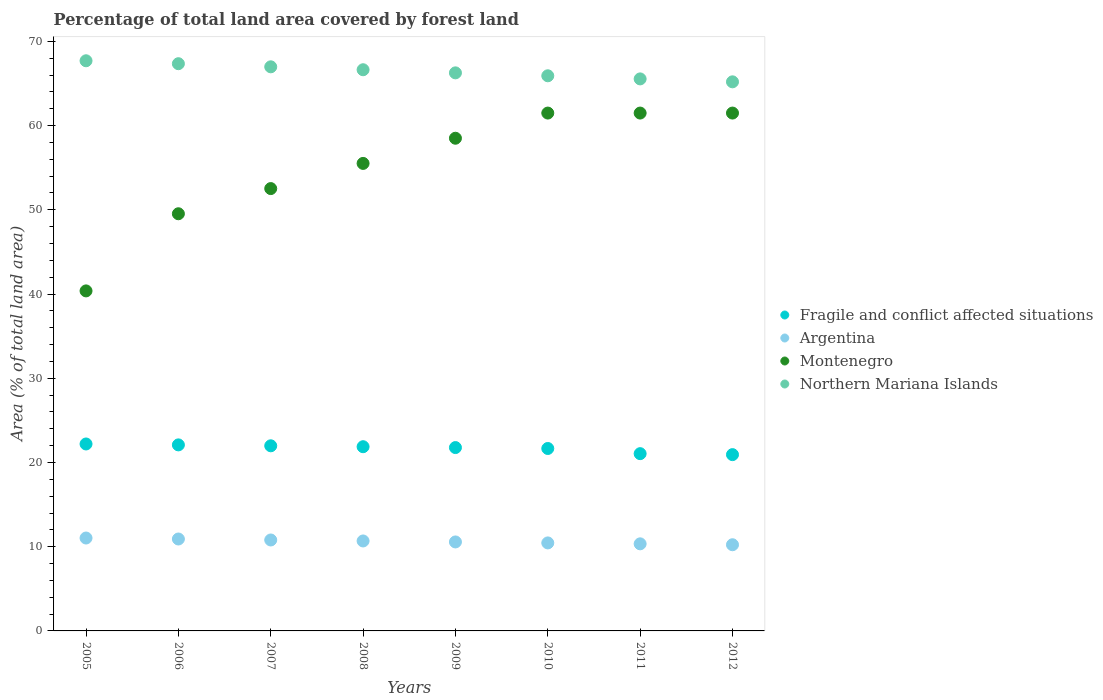Is the number of dotlines equal to the number of legend labels?
Your answer should be very brief. Yes. What is the percentage of forest land in Northern Mariana Islands in 2010?
Your response must be concise. 65.91. Across all years, what is the maximum percentage of forest land in Argentina?
Your response must be concise. 11.03. Across all years, what is the minimum percentage of forest land in Fragile and conflict affected situations?
Your answer should be very brief. 20.93. In which year was the percentage of forest land in Fragile and conflict affected situations minimum?
Offer a very short reply. 2012. What is the total percentage of forest land in Montenegro in the graph?
Offer a very short reply. 440.89. What is the difference between the percentage of forest land in Argentina in 2006 and the percentage of forest land in Montenegro in 2011?
Your answer should be very brief. -50.57. What is the average percentage of forest land in Northern Mariana Islands per year?
Your answer should be very brief. 66.45. In the year 2011, what is the difference between the percentage of forest land in Fragile and conflict affected situations and percentage of forest land in Montenegro?
Provide a short and direct response. -40.44. What is the ratio of the percentage of forest land in Fragile and conflict affected situations in 2008 to that in 2011?
Provide a succinct answer. 1.04. What is the difference between the highest and the lowest percentage of forest land in Argentina?
Your answer should be compact. 0.8. Is the sum of the percentage of forest land in Northern Mariana Islands in 2007 and 2010 greater than the maximum percentage of forest land in Montenegro across all years?
Your answer should be compact. Yes. Is the percentage of forest land in Northern Mariana Islands strictly greater than the percentage of forest land in Argentina over the years?
Provide a succinct answer. Yes. Is the percentage of forest land in Montenegro strictly less than the percentage of forest land in Argentina over the years?
Offer a very short reply. No. How many dotlines are there?
Your response must be concise. 4. How many years are there in the graph?
Provide a succinct answer. 8. Are the values on the major ticks of Y-axis written in scientific E-notation?
Give a very brief answer. No. Does the graph contain grids?
Offer a very short reply. No. Where does the legend appear in the graph?
Provide a short and direct response. Center right. How many legend labels are there?
Give a very brief answer. 4. What is the title of the graph?
Your answer should be very brief. Percentage of total land area covered by forest land. What is the label or title of the Y-axis?
Make the answer very short. Area (% of total land area). What is the Area (% of total land area) in Fragile and conflict affected situations in 2005?
Keep it short and to the point. 22.2. What is the Area (% of total land area) in Argentina in 2005?
Provide a succinct answer. 11.03. What is the Area (% of total land area) in Montenegro in 2005?
Your response must be concise. 40.37. What is the Area (% of total land area) in Northern Mariana Islands in 2005?
Your answer should be very brief. 67.7. What is the Area (% of total land area) in Fragile and conflict affected situations in 2006?
Keep it short and to the point. 22.09. What is the Area (% of total land area) of Argentina in 2006?
Your answer should be compact. 10.91. What is the Area (% of total land area) in Montenegro in 2006?
Your answer should be compact. 49.53. What is the Area (% of total land area) of Northern Mariana Islands in 2006?
Provide a short and direct response. 67.35. What is the Area (% of total land area) of Fragile and conflict affected situations in 2007?
Offer a terse response. 21.98. What is the Area (% of total land area) of Argentina in 2007?
Your response must be concise. 10.8. What is the Area (% of total land area) in Montenegro in 2007?
Ensure brevity in your answer.  52.52. What is the Area (% of total land area) in Northern Mariana Islands in 2007?
Offer a terse response. 66.98. What is the Area (% of total land area) of Fragile and conflict affected situations in 2008?
Provide a short and direct response. 21.87. What is the Area (% of total land area) in Argentina in 2008?
Provide a short and direct response. 10.68. What is the Area (% of total land area) in Montenegro in 2008?
Ensure brevity in your answer.  55.51. What is the Area (% of total land area) in Northern Mariana Islands in 2008?
Give a very brief answer. 66.63. What is the Area (% of total land area) of Fragile and conflict affected situations in 2009?
Your response must be concise. 21.77. What is the Area (% of total land area) of Argentina in 2009?
Keep it short and to the point. 10.57. What is the Area (% of total land area) in Montenegro in 2009?
Provide a succinct answer. 58.5. What is the Area (% of total land area) of Northern Mariana Islands in 2009?
Offer a very short reply. 66.26. What is the Area (% of total land area) in Fragile and conflict affected situations in 2010?
Your answer should be compact. 21.66. What is the Area (% of total land area) in Argentina in 2010?
Your response must be concise. 10.45. What is the Area (% of total land area) in Montenegro in 2010?
Your answer should be compact. 61.49. What is the Area (% of total land area) of Northern Mariana Islands in 2010?
Provide a short and direct response. 65.91. What is the Area (% of total land area) in Fragile and conflict affected situations in 2011?
Your answer should be compact. 21.05. What is the Area (% of total land area) of Argentina in 2011?
Your answer should be very brief. 10.34. What is the Area (% of total land area) of Montenegro in 2011?
Give a very brief answer. 61.49. What is the Area (% of total land area) in Northern Mariana Islands in 2011?
Ensure brevity in your answer.  65.54. What is the Area (% of total land area) of Fragile and conflict affected situations in 2012?
Make the answer very short. 20.93. What is the Area (% of total land area) in Argentina in 2012?
Keep it short and to the point. 10.23. What is the Area (% of total land area) of Montenegro in 2012?
Provide a succinct answer. 61.49. What is the Area (% of total land area) in Northern Mariana Islands in 2012?
Give a very brief answer. 65.2. Across all years, what is the maximum Area (% of total land area) of Fragile and conflict affected situations?
Make the answer very short. 22.2. Across all years, what is the maximum Area (% of total land area) in Argentina?
Your answer should be very brief. 11.03. Across all years, what is the maximum Area (% of total land area) of Montenegro?
Your answer should be compact. 61.49. Across all years, what is the maximum Area (% of total land area) of Northern Mariana Islands?
Your response must be concise. 67.7. Across all years, what is the minimum Area (% of total land area) in Fragile and conflict affected situations?
Offer a terse response. 20.93. Across all years, what is the minimum Area (% of total land area) of Argentina?
Provide a short and direct response. 10.23. Across all years, what is the minimum Area (% of total land area) in Montenegro?
Provide a succinct answer. 40.37. Across all years, what is the minimum Area (% of total land area) in Northern Mariana Islands?
Give a very brief answer. 65.2. What is the total Area (% of total land area) of Fragile and conflict affected situations in the graph?
Ensure brevity in your answer.  173.55. What is the total Area (% of total land area) in Argentina in the graph?
Offer a terse response. 85.01. What is the total Area (% of total land area) in Montenegro in the graph?
Your answer should be very brief. 440.89. What is the total Area (% of total land area) in Northern Mariana Islands in the graph?
Your answer should be compact. 531.57. What is the difference between the Area (% of total land area) of Fragile and conflict affected situations in 2005 and that in 2006?
Your answer should be compact. 0.11. What is the difference between the Area (% of total land area) of Argentina in 2005 and that in 2006?
Your response must be concise. 0.12. What is the difference between the Area (% of total land area) in Montenegro in 2005 and that in 2006?
Keep it short and to the point. -9.16. What is the difference between the Area (% of total land area) in Northern Mariana Islands in 2005 and that in 2006?
Ensure brevity in your answer.  0.35. What is the difference between the Area (% of total land area) of Fragile and conflict affected situations in 2005 and that in 2007?
Your answer should be compact. 0.22. What is the difference between the Area (% of total land area) in Argentina in 2005 and that in 2007?
Your answer should be compact. 0.23. What is the difference between the Area (% of total land area) of Montenegro in 2005 and that in 2007?
Your answer should be very brief. -12.15. What is the difference between the Area (% of total land area) of Northern Mariana Islands in 2005 and that in 2007?
Keep it short and to the point. 0.72. What is the difference between the Area (% of total land area) of Fragile and conflict affected situations in 2005 and that in 2008?
Ensure brevity in your answer.  0.32. What is the difference between the Area (% of total land area) of Argentina in 2005 and that in 2008?
Keep it short and to the point. 0.35. What is the difference between the Area (% of total land area) of Montenegro in 2005 and that in 2008?
Offer a terse response. -15.14. What is the difference between the Area (% of total land area) in Northern Mariana Islands in 2005 and that in 2008?
Your answer should be compact. 1.07. What is the difference between the Area (% of total land area) of Fragile and conflict affected situations in 2005 and that in 2009?
Your answer should be compact. 0.43. What is the difference between the Area (% of total land area) of Argentina in 2005 and that in 2009?
Provide a succinct answer. 0.46. What is the difference between the Area (% of total land area) of Montenegro in 2005 and that in 2009?
Your answer should be very brief. -18.13. What is the difference between the Area (% of total land area) in Northern Mariana Islands in 2005 and that in 2009?
Your answer should be compact. 1.43. What is the difference between the Area (% of total land area) of Fragile and conflict affected situations in 2005 and that in 2010?
Provide a succinct answer. 0.54. What is the difference between the Area (% of total land area) in Argentina in 2005 and that in 2010?
Ensure brevity in your answer.  0.58. What is the difference between the Area (% of total land area) in Montenegro in 2005 and that in 2010?
Keep it short and to the point. -21.12. What is the difference between the Area (% of total land area) in Northern Mariana Islands in 2005 and that in 2010?
Keep it short and to the point. 1.78. What is the difference between the Area (% of total land area) of Fragile and conflict affected situations in 2005 and that in 2011?
Keep it short and to the point. 1.15. What is the difference between the Area (% of total land area) of Argentina in 2005 and that in 2011?
Provide a short and direct response. 0.69. What is the difference between the Area (% of total land area) of Montenegro in 2005 and that in 2011?
Your answer should be very brief. -21.12. What is the difference between the Area (% of total land area) of Northern Mariana Islands in 2005 and that in 2011?
Offer a very short reply. 2.15. What is the difference between the Area (% of total land area) in Fragile and conflict affected situations in 2005 and that in 2012?
Provide a succinct answer. 1.27. What is the difference between the Area (% of total land area) of Argentina in 2005 and that in 2012?
Your answer should be very brief. 0.8. What is the difference between the Area (% of total land area) in Montenegro in 2005 and that in 2012?
Provide a short and direct response. -21.12. What is the difference between the Area (% of total land area) of Northern Mariana Islands in 2005 and that in 2012?
Ensure brevity in your answer.  2.5. What is the difference between the Area (% of total land area) of Fragile and conflict affected situations in 2006 and that in 2007?
Make the answer very short. 0.11. What is the difference between the Area (% of total land area) of Argentina in 2006 and that in 2007?
Give a very brief answer. 0.12. What is the difference between the Area (% of total land area) in Montenegro in 2006 and that in 2007?
Keep it short and to the point. -2.99. What is the difference between the Area (% of total land area) of Northern Mariana Islands in 2006 and that in 2007?
Offer a very short reply. 0.37. What is the difference between the Area (% of total land area) of Fragile and conflict affected situations in 2006 and that in 2008?
Provide a short and direct response. 0.22. What is the difference between the Area (% of total land area) of Argentina in 2006 and that in 2008?
Give a very brief answer. 0.23. What is the difference between the Area (% of total land area) of Montenegro in 2006 and that in 2008?
Provide a succinct answer. -5.98. What is the difference between the Area (% of total land area) in Northern Mariana Islands in 2006 and that in 2008?
Offer a terse response. 0.72. What is the difference between the Area (% of total land area) of Fragile and conflict affected situations in 2006 and that in 2009?
Keep it short and to the point. 0.32. What is the difference between the Area (% of total land area) in Argentina in 2006 and that in 2009?
Offer a terse response. 0.35. What is the difference between the Area (% of total land area) in Montenegro in 2006 and that in 2009?
Give a very brief answer. -8.97. What is the difference between the Area (% of total land area) of Northern Mariana Islands in 2006 and that in 2009?
Your answer should be compact. 1.09. What is the difference between the Area (% of total land area) of Fragile and conflict affected situations in 2006 and that in 2010?
Offer a terse response. 0.43. What is the difference between the Area (% of total land area) of Argentina in 2006 and that in 2010?
Provide a short and direct response. 0.46. What is the difference between the Area (% of total land area) in Montenegro in 2006 and that in 2010?
Your answer should be very brief. -11.96. What is the difference between the Area (% of total land area) of Northern Mariana Islands in 2006 and that in 2010?
Offer a terse response. 1.43. What is the difference between the Area (% of total land area) of Fragile and conflict affected situations in 2006 and that in 2011?
Make the answer very short. 1.04. What is the difference between the Area (% of total land area) in Argentina in 2006 and that in 2011?
Ensure brevity in your answer.  0.57. What is the difference between the Area (% of total land area) in Montenegro in 2006 and that in 2011?
Provide a succinct answer. -11.96. What is the difference between the Area (% of total land area) in Northern Mariana Islands in 2006 and that in 2011?
Your answer should be very brief. 1.8. What is the difference between the Area (% of total land area) in Fragile and conflict affected situations in 2006 and that in 2012?
Offer a terse response. 1.16. What is the difference between the Area (% of total land area) of Argentina in 2006 and that in 2012?
Offer a very short reply. 0.68. What is the difference between the Area (% of total land area) in Montenegro in 2006 and that in 2012?
Ensure brevity in your answer.  -11.96. What is the difference between the Area (% of total land area) in Northern Mariana Islands in 2006 and that in 2012?
Your answer should be very brief. 2.15. What is the difference between the Area (% of total land area) in Fragile and conflict affected situations in 2007 and that in 2008?
Provide a short and direct response. 0.11. What is the difference between the Area (% of total land area) of Argentina in 2007 and that in 2008?
Give a very brief answer. 0.12. What is the difference between the Area (% of total land area) in Montenegro in 2007 and that in 2008?
Provide a short and direct response. -2.99. What is the difference between the Area (% of total land area) in Northern Mariana Islands in 2007 and that in 2008?
Keep it short and to the point. 0.35. What is the difference between the Area (% of total land area) of Fragile and conflict affected situations in 2007 and that in 2009?
Ensure brevity in your answer.  0.21. What is the difference between the Area (% of total land area) in Argentina in 2007 and that in 2009?
Provide a succinct answer. 0.23. What is the difference between the Area (% of total land area) of Montenegro in 2007 and that in 2009?
Your answer should be very brief. -5.98. What is the difference between the Area (% of total land area) in Northern Mariana Islands in 2007 and that in 2009?
Your answer should be very brief. 0.72. What is the difference between the Area (% of total land area) of Fragile and conflict affected situations in 2007 and that in 2010?
Give a very brief answer. 0.32. What is the difference between the Area (% of total land area) in Argentina in 2007 and that in 2010?
Provide a short and direct response. 0.35. What is the difference between the Area (% of total land area) in Montenegro in 2007 and that in 2010?
Your answer should be compact. -8.97. What is the difference between the Area (% of total land area) of Northern Mariana Islands in 2007 and that in 2010?
Provide a short and direct response. 1.07. What is the difference between the Area (% of total land area) in Fragile and conflict affected situations in 2007 and that in 2011?
Your response must be concise. 0.93. What is the difference between the Area (% of total land area) of Argentina in 2007 and that in 2011?
Provide a short and direct response. 0.46. What is the difference between the Area (% of total land area) of Montenegro in 2007 and that in 2011?
Make the answer very short. -8.97. What is the difference between the Area (% of total land area) of Northern Mariana Islands in 2007 and that in 2011?
Offer a terse response. 1.43. What is the difference between the Area (% of total land area) in Fragile and conflict affected situations in 2007 and that in 2012?
Make the answer very short. 1.05. What is the difference between the Area (% of total land area) of Argentina in 2007 and that in 2012?
Make the answer very short. 0.57. What is the difference between the Area (% of total land area) of Montenegro in 2007 and that in 2012?
Provide a short and direct response. -8.97. What is the difference between the Area (% of total land area) of Northern Mariana Islands in 2007 and that in 2012?
Give a very brief answer. 1.78. What is the difference between the Area (% of total land area) in Fragile and conflict affected situations in 2008 and that in 2009?
Give a very brief answer. 0.1. What is the difference between the Area (% of total land area) in Argentina in 2008 and that in 2009?
Keep it short and to the point. 0.12. What is the difference between the Area (% of total land area) of Montenegro in 2008 and that in 2009?
Offer a very short reply. -2.99. What is the difference between the Area (% of total land area) of Northern Mariana Islands in 2008 and that in 2009?
Offer a very short reply. 0.37. What is the difference between the Area (% of total land area) in Fragile and conflict affected situations in 2008 and that in 2010?
Offer a terse response. 0.21. What is the difference between the Area (% of total land area) of Argentina in 2008 and that in 2010?
Ensure brevity in your answer.  0.23. What is the difference between the Area (% of total land area) in Montenegro in 2008 and that in 2010?
Your answer should be compact. -5.98. What is the difference between the Area (% of total land area) of Northern Mariana Islands in 2008 and that in 2010?
Your response must be concise. 0.72. What is the difference between the Area (% of total land area) of Fragile and conflict affected situations in 2008 and that in 2011?
Make the answer very short. 0.83. What is the difference between the Area (% of total land area) of Argentina in 2008 and that in 2011?
Your answer should be very brief. 0.34. What is the difference between the Area (% of total land area) in Montenegro in 2008 and that in 2011?
Give a very brief answer. -5.98. What is the difference between the Area (% of total land area) in Northern Mariana Islands in 2008 and that in 2011?
Provide a succinct answer. 1.09. What is the difference between the Area (% of total land area) in Fragile and conflict affected situations in 2008 and that in 2012?
Offer a very short reply. 0.94. What is the difference between the Area (% of total land area) of Argentina in 2008 and that in 2012?
Ensure brevity in your answer.  0.45. What is the difference between the Area (% of total land area) in Montenegro in 2008 and that in 2012?
Make the answer very short. -5.98. What is the difference between the Area (% of total land area) of Northern Mariana Islands in 2008 and that in 2012?
Provide a succinct answer. 1.43. What is the difference between the Area (% of total land area) of Fragile and conflict affected situations in 2009 and that in 2010?
Your answer should be compact. 0.11. What is the difference between the Area (% of total land area) in Argentina in 2009 and that in 2010?
Offer a terse response. 0.12. What is the difference between the Area (% of total land area) of Montenegro in 2009 and that in 2010?
Make the answer very short. -2.99. What is the difference between the Area (% of total land area) in Northern Mariana Islands in 2009 and that in 2010?
Offer a very short reply. 0.35. What is the difference between the Area (% of total land area) in Fragile and conflict affected situations in 2009 and that in 2011?
Your response must be concise. 0.72. What is the difference between the Area (% of total land area) of Argentina in 2009 and that in 2011?
Provide a short and direct response. 0.22. What is the difference between the Area (% of total land area) in Montenegro in 2009 and that in 2011?
Give a very brief answer. -2.99. What is the difference between the Area (% of total land area) in Northern Mariana Islands in 2009 and that in 2011?
Provide a short and direct response. 0.72. What is the difference between the Area (% of total land area) of Fragile and conflict affected situations in 2009 and that in 2012?
Keep it short and to the point. 0.84. What is the difference between the Area (% of total land area) in Argentina in 2009 and that in 2012?
Give a very brief answer. 0.33. What is the difference between the Area (% of total land area) in Montenegro in 2009 and that in 2012?
Make the answer very short. -2.99. What is the difference between the Area (% of total land area) of Northern Mariana Islands in 2009 and that in 2012?
Your answer should be very brief. 1.07. What is the difference between the Area (% of total land area) in Fragile and conflict affected situations in 2010 and that in 2011?
Provide a succinct answer. 0.61. What is the difference between the Area (% of total land area) in Argentina in 2010 and that in 2011?
Make the answer very short. 0.11. What is the difference between the Area (% of total land area) of Northern Mariana Islands in 2010 and that in 2011?
Your answer should be compact. 0.37. What is the difference between the Area (% of total land area) of Fragile and conflict affected situations in 2010 and that in 2012?
Offer a very short reply. 0.73. What is the difference between the Area (% of total land area) in Argentina in 2010 and that in 2012?
Offer a terse response. 0.22. What is the difference between the Area (% of total land area) in Montenegro in 2010 and that in 2012?
Provide a succinct answer. 0. What is the difference between the Area (% of total land area) of Northern Mariana Islands in 2010 and that in 2012?
Your response must be concise. 0.72. What is the difference between the Area (% of total land area) of Fragile and conflict affected situations in 2011 and that in 2012?
Give a very brief answer. 0.12. What is the difference between the Area (% of total land area) of Argentina in 2011 and that in 2012?
Your answer should be very brief. 0.11. What is the difference between the Area (% of total land area) of Montenegro in 2011 and that in 2012?
Your answer should be very brief. 0. What is the difference between the Area (% of total land area) in Northern Mariana Islands in 2011 and that in 2012?
Your answer should be compact. 0.35. What is the difference between the Area (% of total land area) in Fragile and conflict affected situations in 2005 and the Area (% of total land area) in Argentina in 2006?
Provide a short and direct response. 11.28. What is the difference between the Area (% of total land area) in Fragile and conflict affected situations in 2005 and the Area (% of total land area) in Montenegro in 2006?
Give a very brief answer. -27.33. What is the difference between the Area (% of total land area) in Fragile and conflict affected situations in 2005 and the Area (% of total land area) in Northern Mariana Islands in 2006?
Your answer should be very brief. -45.15. What is the difference between the Area (% of total land area) of Argentina in 2005 and the Area (% of total land area) of Montenegro in 2006?
Make the answer very short. -38.5. What is the difference between the Area (% of total land area) in Argentina in 2005 and the Area (% of total land area) in Northern Mariana Islands in 2006?
Provide a short and direct response. -56.32. What is the difference between the Area (% of total land area) in Montenegro in 2005 and the Area (% of total land area) in Northern Mariana Islands in 2006?
Ensure brevity in your answer.  -26.98. What is the difference between the Area (% of total land area) of Fragile and conflict affected situations in 2005 and the Area (% of total land area) of Argentina in 2007?
Your answer should be very brief. 11.4. What is the difference between the Area (% of total land area) in Fragile and conflict affected situations in 2005 and the Area (% of total land area) in Montenegro in 2007?
Your answer should be very brief. -30.32. What is the difference between the Area (% of total land area) in Fragile and conflict affected situations in 2005 and the Area (% of total land area) in Northern Mariana Islands in 2007?
Give a very brief answer. -44.78. What is the difference between the Area (% of total land area) of Argentina in 2005 and the Area (% of total land area) of Montenegro in 2007?
Your response must be concise. -41.49. What is the difference between the Area (% of total land area) in Argentina in 2005 and the Area (% of total land area) in Northern Mariana Islands in 2007?
Your answer should be compact. -55.95. What is the difference between the Area (% of total land area) of Montenegro in 2005 and the Area (% of total land area) of Northern Mariana Islands in 2007?
Ensure brevity in your answer.  -26.61. What is the difference between the Area (% of total land area) of Fragile and conflict affected situations in 2005 and the Area (% of total land area) of Argentina in 2008?
Your answer should be very brief. 11.52. What is the difference between the Area (% of total land area) of Fragile and conflict affected situations in 2005 and the Area (% of total land area) of Montenegro in 2008?
Your response must be concise. -33.31. What is the difference between the Area (% of total land area) of Fragile and conflict affected situations in 2005 and the Area (% of total land area) of Northern Mariana Islands in 2008?
Make the answer very short. -44.43. What is the difference between the Area (% of total land area) of Argentina in 2005 and the Area (% of total land area) of Montenegro in 2008?
Offer a very short reply. -44.48. What is the difference between the Area (% of total land area) of Argentina in 2005 and the Area (% of total land area) of Northern Mariana Islands in 2008?
Your response must be concise. -55.6. What is the difference between the Area (% of total land area) of Montenegro in 2005 and the Area (% of total land area) of Northern Mariana Islands in 2008?
Give a very brief answer. -26.26. What is the difference between the Area (% of total land area) of Fragile and conflict affected situations in 2005 and the Area (% of total land area) of Argentina in 2009?
Your answer should be compact. 11.63. What is the difference between the Area (% of total land area) in Fragile and conflict affected situations in 2005 and the Area (% of total land area) in Montenegro in 2009?
Your response must be concise. -36.3. What is the difference between the Area (% of total land area) of Fragile and conflict affected situations in 2005 and the Area (% of total land area) of Northern Mariana Islands in 2009?
Make the answer very short. -44.06. What is the difference between the Area (% of total land area) of Argentina in 2005 and the Area (% of total land area) of Montenegro in 2009?
Keep it short and to the point. -47.47. What is the difference between the Area (% of total land area) of Argentina in 2005 and the Area (% of total land area) of Northern Mariana Islands in 2009?
Offer a very short reply. -55.23. What is the difference between the Area (% of total land area) of Montenegro in 2005 and the Area (% of total land area) of Northern Mariana Islands in 2009?
Provide a short and direct response. -25.89. What is the difference between the Area (% of total land area) of Fragile and conflict affected situations in 2005 and the Area (% of total land area) of Argentina in 2010?
Your answer should be very brief. 11.75. What is the difference between the Area (% of total land area) in Fragile and conflict affected situations in 2005 and the Area (% of total land area) in Montenegro in 2010?
Your response must be concise. -39.29. What is the difference between the Area (% of total land area) in Fragile and conflict affected situations in 2005 and the Area (% of total land area) in Northern Mariana Islands in 2010?
Provide a short and direct response. -43.72. What is the difference between the Area (% of total land area) in Argentina in 2005 and the Area (% of total land area) in Montenegro in 2010?
Make the answer very short. -50.46. What is the difference between the Area (% of total land area) of Argentina in 2005 and the Area (% of total land area) of Northern Mariana Islands in 2010?
Your answer should be compact. -54.88. What is the difference between the Area (% of total land area) in Montenegro in 2005 and the Area (% of total land area) in Northern Mariana Islands in 2010?
Provide a succinct answer. -25.54. What is the difference between the Area (% of total land area) in Fragile and conflict affected situations in 2005 and the Area (% of total land area) in Argentina in 2011?
Provide a succinct answer. 11.86. What is the difference between the Area (% of total land area) in Fragile and conflict affected situations in 2005 and the Area (% of total land area) in Montenegro in 2011?
Give a very brief answer. -39.29. What is the difference between the Area (% of total land area) in Fragile and conflict affected situations in 2005 and the Area (% of total land area) in Northern Mariana Islands in 2011?
Make the answer very short. -43.35. What is the difference between the Area (% of total land area) in Argentina in 2005 and the Area (% of total land area) in Montenegro in 2011?
Your response must be concise. -50.46. What is the difference between the Area (% of total land area) in Argentina in 2005 and the Area (% of total land area) in Northern Mariana Islands in 2011?
Give a very brief answer. -54.51. What is the difference between the Area (% of total land area) of Montenegro in 2005 and the Area (% of total land area) of Northern Mariana Islands in 2011?
Your response must be concise. -25.17. What is the difference between the Area (% of total land area) in Fragile and conflict affected situations in 2005 and the Area (% of total land area) in Argentina in 2012?
Offer a terse response. 11.96. What is the difference between the Area (% of total land area) in Fragile and conflict affected situations in 2005 and the Area (% of total land area) in Montenegro in 2012?
Keep it short and to the point. -39.29. What is the difference between the Area (% of total land area) in Fragile and conflict affected situations in 2005 and the Area (% of total land area) in Northern Mariana Islands in 2012?
Keep it short and to the point. -43. What is the difference between the Area (% of total land area) of Argentina in 2005 and the Area (% of total land area) of Montenegro in 2012?
Offer a very short reply. -50.46. What is the difference between the Area (% of total land area) of Argentina in 2005 and the Area (% of total land area) of Northern Mariana Islands in 2012?
Offer a terse response. -54.17. What is the difference between the Area (% of total land area) of Montenegro in 2005 and the Area (% of total land area) of Northern Mariana Islands in 2012?
Provide a short and direct response. -24.82. What is the difference between the Area (% of total land area) of Fragile and conflict affected situations in 2006 and the Area (% of total land area) of Argentina in 2007?
Your answer should be very brief. 11.29. What is the difference between the Area (% of total land area) in Fragile and conflict affected situations in 2006 and the Area (% of total land area) in Montenegro in 2007?
Provide a succinct answer. -30.43. What is the difference between the Area (% of total land area) in Fragile and conflict affected situations in 2006 and the Area (% of total land area) in Northern Mariana Islands in 2007?
Your response must be concise. -44.89. What is the difference between the Area (% of total land area) of Argentina in 2006 and the Area (% of total land area) of Montenegro in 2007?
Provide a short and direct response. -41.61. What is the difference between the Area (% of total land area) in Argentina in 2006 and the Area (% of total land area) in Northern Mariana Islands in 2007?
Give a very brief answer. -56.06. What is the difference between the Area (% of total land area) of Montenegro in 2006 and the Area (% of total land area) of Northern Mariana Islands in 2007?
Your answer should be very brief. -17.45. What is the difference between the Area (% of total land area) of Fragile and conflict affected situations in 2006 and the Area (% of total land area) of Argentina in 2008?
Provide a short and direct response. 11.41. What is the difference between the Area (% of total land area) of Fragile and conflict affected situations in 2006 and the Area (% of total land area) of Montenegro in 2008?
Keep it short and to the point. -33.42. What is the difference between the Area (% of total land area) in Fragile and conflict affected situations in 2006 and the Area (% of total land area) in Northern Mariana Islands in 2008?
Make the answer very short. -44.54. What is the difference between the Area (% of total land area) in Argentina in 2006 and the Area (% of total land area) in Montenegro in 2008?
Make the answer very short. -44.6. What is the difference between the Area (% of total land area) in Argentina in 2006 and the Area (% of total land area) in Northern Mariana Islands in 2008?
Give a very brief answer. -55.72. What is the difference between the Area (% of total land area) of Montenegro in 2006 and the Area (% of total land area) of Northern Mariana Islands in 2008?
Provide a succinct answer. -17.1. What is the difference between the Area (% of total land area) of Fragile and conflict affected situations in 2006 and the Area (% of total land area) of Argentina in 2009?
Provide a short and direct response. 11.52. What is the difference between the Area (% of total land area) of Fragile and conflict affected situations in 2006 and the Area (% of total land area) of Montenegro in 2009?
Your answer should be compact. -36.41. What is the difference between the Area (% of total land area) of Fragile and conflict affected situations in 2006 and the Area (% of total land area) of Northern Mariana Islands in 2009?
Give a very brief answer. -44.17. What is the difference between the Area (% of total land area) of Argentina in 2006 and the Area (% of total land area) of Montenegro in 2009?
Provide a succinct answer. -47.58. What is the difference between the Area (% of total land area) of Argentina in 2006 and the Area (% of total land area) of Northern Mariana Islands in 2009?
Make the answer very short. -55.35. What is the difference between the Area (% of total land area) in Montenegro in 2006 and the Area (% of total land area) in Northern Mariana Islands in 2009?
Your answer should be compact. -16.73. What is the difference between the Area (% of total land area) in Fragile and conflict affected situations in 2006 and the Area (% of total land area) in Argentina in 2010?
Your response must be concise. 11.64. What is the difference between the Area (% of total land area) of Fragile and conflict affected situations in 2006 and the Area (% of total land area) of Montenegro in 2010?
Provide a short and direct response. -39.4. What is the difference between the Area (% of total land area) of Fragile and conflict affected situations in 2006 and the Area (% of total land area) of Northern Mariana Islands in 2010?
Offer a terse response. -43.82. What is the difference between the Area (% of total land area) in Argentina in 2006 and the Area (% of total land area) in Montenegro in 2010?
Your response must be concise. -50.57. What is the difference between the Area (% of total land area) of Argentina in 2006 and the Area (% of total land area) of Northern Mariana Islands in 2010?
Make the answer very short. -55. What is the difference between the Area (% of total land area) in Montenegro in 2006 and the Area (% of total land area) in Northern Mariana Islands in 2010?
Give a very brief answer. -16.38. What is the difference between the Area (% of total land area) in Fragile and conflict affected situations in 2006 and the Area (% of total land area) in Argentina in 2011?
Offer a very short reply. 11.75. What is the difference between the Area (% of total land area) in Fragile and conflict affected situations in 2006 and the Area (% of total land area) in Montenegro in 2011?
Your response must be concise. -39.4. What is the difference between the Area (% of total land area) in Fragile and conflict affected situations in 2006 and the Area (% of total land area) in Northern Mariana Islands in 2011?
Provide a succinct answer. -43.45. What is the difference between the Area (% of total land area) of Argentina in 2006 and the Area (% of total land area) of Montenegro in 2011?
Give a very brief answer. -50.57. What is the difference between the Area (% of total land area) of Argentina in 2006 and the Area (% of total land area) of Northern Mariana Islands in 2011?
Offer a very short reply. -54.63. What is the difference between the Area (% of total land area) of Montenegro in 2006 and the Area (% of total land area) of Northern Mariana Islands in 2011?
Offer a very short reply. -16.01. What is the difference between the Area (% of total land area) of Fragile and conflict affected situations in 2006 and the Area (% of total land area) of Argentina in 2012?
Give a very brief answer. 11.86. What is the difference between the Area (% of total land area) in Fragile and conflict affected situations in 2006 and the Area (% of total land area) in Montenegro in 2012?
Your answer should be very brief. -39.4. What is the difference between the Area (% of total land area) of Fragile and conflict affected situations in 2006 and the Area (% of total land area) of Northern Mariana Islands in 2012?
Your answer should be very brief. -43.11. What is the difference between the Area (% of total land area) in Argentina in 2006 and the Area (% of total land area) in Montenegro in 2012?
Offer a very short reply. -50.57. What is the difference between the Area (% of total land area) of Argentina in 2006 and the Area (% of total land area) of Northern Mariana Islands in 2012?
Your answer should be compact. -54.28. What is the difference between the Area (% of total land area) of Montenegro in 2006 and the Area (% of total land area) of Northern Mariana Islands in 2012?
Provide a succinct answer. -15.66. What is the difference between the Area (% of total land area) of Fragile and conflict affected situations in 2007 and the Area (% of total land area) of Argentina in 2008?
Keep it short and to the point. 11.3. What is the difference between the Area (% of total land area) in Fragile and conflict affected situations in 2007 and the Area (% of total land area) in Montenegro in 2008?
Keep it short and to the point. -33.53. What is the difference between the Area (% of total land area) in Fragile and conflict affected situations in 2007 and the Area (% of total land area) in Northern Mariana Islands in 2008?
Give a very brief answer. -44.65. What is the difference between the Area (% of total land area) in Argentina in 2007 and the Area (% of total land area) in Montenegro in 2008?
Offer a very short reply. -44.71. What is the difference between the Area (% of total land area) in Argentina in 2007 and the Area (% of total land area) in Northern Mariana Islands in 2008?
Ensure brevity in your answer.  -55.83. What is the difference between the Area (% of total land area) in Montenegro in 2007 and the Area (% of total land area) in Northern Mariana Islands in 2008?
Offer a very short reply. -14.11. What is the difference between the Area (% of total land area) of Fragile and conflict affected situations in 2007 and the Area (% of total land area) of Argentina in 2009?
Offer a very short reply. 11.41. What is the difference between the Area (% of total land area) of Fragile and conflict affected situations in 2007 and the Area (% of total land area) of Montenegro in 2009?
Offer a terse response. -36.52. What is the difference between the Area (% of total land area) of Fragile and conflict affected situations in 2007 and the Area (% of total land area) of Northern Mariana Islands in 2009?
Offer a very short reply. -44.28. What is the difference between the Area (% of total land area) of Argentina in 2007 and the Area (% of total land area) of Montenegro in 2009?
Ensure brevity in your answer.  -47.7. What is the difference between the Area (% of total land area) in Argentina in 2007 and the Area (% of total land area) in Northern Mariana Islands in 2009?
Your response must be concise. -55.46. What is the difference between the Area (% of total land area) in Montenegro in 2007 and the Area (% of total land area) in Northern Mariana Islands in 2009?
Give a very brief answer. -13.74. What is the difference between the Area (% of total land area) of Fragile and conflict affected situations in 2007 and the Area (% of total land area) of Argentina in 2010?
Offer a very short reply. 11.53. What is the difference between the Area (% of total land area) in Fragile and conflict affected situations in 2007 and the Area (% of total land area) in Montenegro in 2010?
Give a very brief answer. -39.51. What is the difference between the Area (% of total land area) of Fragile and conflict affected situations in 2007 and the Area (% of total land area) of Northern Mariana Islands in 2010?
Provide a succinct answer. -43.93. What is the difference between the Area (% of total land area) of Argentina in 2007 and the Area (% of total land area) of Montenegro in 2010?
Ensure brevity in your answer.  -50.69. What is the difference between the Area (% of total land area) of Argentina in 2007 and the Area (% of total land area) of Northern Mariana Islands in 2010?
Ensure brevity in your answer.  -55.12. What is the difference between the Area (% of total land area) of Montenegro in 2007 and the Area (% of total land area) of Northern Mariana Islands in 2010?
Offer a very short reply. -13.39. What is the difference between the Area (% of total land area) of Fragile and conflict affected situations in 2007 and the Area (% of total land area) of Argentina in 2011?
Offer a very short reply. 11.64. What is the difference between the Area (% of total land area) of Fragile and conflict affected situations in 2007 and the Area (% of total land area) of Montenegro in 2011?
Ensure brevity in your answer.  -39.51. What is the difference between the Area (% of total land area) in Fragile and conflict affected situations in 2007 and the Area (% of total land area) in Northern Mariana Islands in 2011?
Ensure brevity in your answer.  -43.56. What is the difference between the Area (% of total land area) of Argentina in 2007 and the Area (% of total land area) of Montenegro in 2011?
Provide a succinct answer. -50.69. What is the difference between the Area (% of total land area) of Argentina in 2007 and the Area (% of total land area) of Northern Mariana Islands in 2011?
Keep it short and to the point. -54.75. What is the difference between the Area (% of total land area) in Montenegro in 2007 and the Area (% of total land area) in Northern Mariana Islands in 2011?
Your response must be concise. -13.02. What is the difference between the Area (% of total land area) in Fragile and conflict affected situations in 2007 and the Area (% of total land area) in Argentina in 2012?
Your response must be concise. 11.75. What is the difference between the Area (% of total land area) in Fragile and conflict affected situations in 2007 and the Area (% of total land area) in Montenegro in 2012?
Offer a very short reply. -39.51. What is the difference between the Area (% of total land area) of Fragile and conflict affected situations in 2007 and the Area (% of total land area) of Northern Mariana Islands in 2012?
Your answer should be compact. -43.22. What is the difference between the Area (% of total land area) in Argentina in 2007 and the Area (% of total land area) in Montenegro in 2012?
Offer a very short reply. -50.69. What is the difference between the Area (% of total land area) of Argentina in 2007 and the Area (% of total land area) of Northern Mariana Islands in 2012?
Your answer should be compact. -54.4. What is the difference between the Area (% of total land area) in Montenegro in 2007 and the Area (% of total land area) in Northern Mariana Islands in 2012?
Your answer should be very brief. -12.68. What is the difference between the Area (% of total land area) of Fragile and conflict affected situations in 2008 and the Area (% of total land area) of Argentina in 2009?
Provide a short and direct response. 11.31. What is the difference between the Area (% of total land area) in Fragile and conflict affected situations in 2008 and the Area (% of total land area) in Montenegro in 2009?
Your response must be concise. -36.63. What is the difference between the Area (% of total land area) of Fragile and conflict affected situations in 2008 and the Area (% of total land area) of Northern Mariana Islands in 2009?
Keep it short and to the point. -44.39. What is the difference between the Area (% of total land area) in Argentina in 2008 and the Area (% of total land area) in Montenegro in 2009?
Ensure brevity in your answer.  -47.82. What is the difference between the Area (% of total land area) in Argentina in 2008 and the Area (% of total land area) in Northern Mariana Islands in 2009?
Offer a terse response. -55.58. What is the difference between the Area (% of total land area) in Montenegro in 2008 and the Area (% of total land area) in Northern Mariana Islands in 2009?
Keep it short and to the point. -10.75. What is the difference between the Area (% of total land area) in Fragile and conflict affected situations in 2008 and the Area (% of total land area) in Argentina in 2010?
Your answer should be compact. 11.42. What is the difference between the Area (% of total land area) of Fragile and conflict affected situations in 2008 and the Area (% of total land area) of Montenegro in 2010?
Offer a terse response. -39.61. What is the difference between the Area (% of total land area) in Fragile and conflict affected situations in 2008 and the Area (% of total land area) in Northern Mariana Islands in 2010?
Provide a succinct answer. -44.04. What is the difference between the Area (% of total land area) in Argentina in 2008 and the Area (% of total land area) in Montenegro in 2010?
Ensure brevity in your answer.  -50.81. What is the difference between the Area (% of total land area) of Argentina in 2008 and the Area (% of total land area) of Northern Mariana Islands in 2010?
Provide a short and direct response. -55.23. What is the difference between the Area (% of total land area) in Montenegro in 2008 and the Area (% of total land area) in Northern Mariana Islands in 2010?
Your answer should be very brief. -10.4. What is the difference between the Area (% of total land area) in Fragile and conflict affected situations in 2008 and the Area (% of total land area) in Argentina in 2011?
Offer a terse response. 11.53. What is the difference between the Area (% of total land area) of Fragile and conflict affected situations in 2008 and the Area (% of total land area) of Montenegro in 2011?
Keep it short and to the point. -39.61. What is the difference between the Area (% of total land area) of Fragile and conflict affected situations in 2008 and the Area (% of total land area) of Northern Mariana Islands in 2011?
Give a very brief answer. -43.67. What is the difference between the Area (% of total land area) in Argentina in 2008 and the Area (% of total land area) in Montenegro in 2011?
Offer a very short reply. -50.81. What is the difference between the Area (% of total land area) in Argentina in 2008 and the Area (% of total land area) in Northern Mariana Islands in 2011?
Provide a succinct answer. -54.86. What is the difference between the Area (% of total land area) of Montenegro in 2008 and the Area (% of total land area) of Northern Mariana Islands in 2011?
Give a very brief answer. -10.03. What is the difference between the Area (% of total land area) of Fragile and conflict affected situations in 2008 and the Area (% of total land area) of Argentina in 2012?
Your response must be concise. 11.64. What is the difference between the Area (% of total land area) of Fragile and conflict affected situations in 2008 and the Area (% of total land area) of Montenegro in 2012?
Keep it short and to the point. -39.61. What is the difference between the Area (% of total land area) in Fragile and conflict affected situations in 2008 and the Area (% of total land area) in Northern Mariana Islands in 2012?
Ensure brevity in your answer.  -43.32. What is the difference between the Area (% of total land area) of Argentina in 2008 and the Area (% of total land area) of Montenegro in 2012?
Make the answer very short. -50.81. What is the difference between the Area (% of total land area) of Argentina in 2008 and the Area (% of total land area) of Northern Mariana Islands in 2012?
Offer a terse response. -54.51. What is the difference between the Area (% of total land area) in Montenegro in 2008 and the Area (% of total land area) in Northern Mariana Islands in 2012?
Your answer should be compact. -9.69. What is the difference between the Area (% of total land area) in Fragile and conflict affected situations in 2009 and the Area (% of total land area) in Argentina in 2010?
Provide a succinct answer. 11.32. What is the difference between the Area (% of total land area) in Fragile and conflict affected situations in 2009 and the Area (% of total land area) in Montenegro in 2010?
Provide a short and direct response. -39.72. What is the difference between the Area (% of total land area) of Fragile and conflict affected situations in 2009 and the Area (% of total land area) of Northern Mariana Islands in 2010?
Offer a very short reply. -44.14. What is the difference between the Area (% of total land area) of Argentina in 2009 and the Area (% of total land area) of Montenegro in 2010?
Make the answer very short. -50.92. What is the difference between the Area (% of total land area) in Argentina in 2009 and the Area (% of total land area) in Northern Mariana Islands in 2010?
Offer a terse response. -55.35. What is the difference between the Area (% of total land area) of Montenegro in 2009 and the Area (% of total land area) of Northern Mariana Islands in 2010?
Ensure brevity in your answer.  -7.41. What is the difference between the Area (% of total land area) in Fragile and conflict affected situations in 2009 and the Area (% of total land area) in Argentina in 2011?
Ensure brevity in your answer.  11.43. What is the difference between the Area (% of total land area) of Fragile and conflict affected situations in 2009 and the Area (% of total land area) of Montenegro in 2011?
Offer a very short reply. -39.72. What is the difference between the Area (% of total land area) in Fragile and conflict affected situations in 2009 and the Area (% of total land area) in Northern Mariana Islands in 2011?
Give a very brief answer. -43.77. What is the difference between the Area (% of total land area) in Argentina in 2009 and the Area (% of total land area) in Montenegro in 2011?
Your response must be concise. -50.92. What is the difference between the Area (% of total land area) of Argentina in 2009 and the Area (% of total land area) of Northern Mariana Islands in 2011?
Provide a succinct answer. -54.98. What is the difference between the Area (% of total land area) in Montenegro in 2009 and the Area (% of total land area) in Northern Mariana Islands in 2011?
Ensure brevity in your answer.  -7.05. What is the difference between the Area (% of total land area) in Fragile and conflict affected situations in 2009 and the Area (% of total land area) in Argentina in 2012?
Make the answer very short. 11.54. What is the difference between the Area (% of total land area) of Fragile and conflict affected situations in 2009 and the Area (% of total land area) of Montenegro in 2012?
Offer a very short reply. -39.72. What is the difference between the Area (% of total land area) in Fragile and conflict affected situations in 2009 and the Area (% of total land area) in Northern Mariana Islands in 2012?
Ensure brevity in your answer.  -43.43. What is the difference between the Area (% of total land area) of Argentina in 2009 and the Area (% of total land area) of Montenegro in 2012?
Your answer should be very brief. -50.92. What is the difference between the Area (% of total land area) of Argentina in 2009 and the Area (% of total land area) of Northern Mariana Islands in 2012?
Keep it short and to the point. -54.63. What is the difference between the Area (% of total land area) in Montenegro in 2009 and the Area (% of total land area) in Northern Mariana Islands in 2012?
Provide a succinct answer. -6.7. What is the difference between the Area (% of total land area) of Fragile and conflict affected situations in 2010 and the Area (% of total land area) of Argentina in 2011?
Offer a very short reply. 11.32. What is the difference between the Area (% of total land area) in Fragile and conflict affected situations in 2010 and the Area (% of total land area) in Montenegro in 2011?
Ensure brevity in your answer.  -39.83. What is the difference between the Area (% of total land area) in Fragile and conflict affected situations in 2010 and the Area (% of total land area) in Northern Mariana Islands in 2011?
Give a very brief answer. -43.88. What is the difference between the Area (% of total land area) in Argentina in 2010 and the Area (% of total land area) in Montenegro in 2011?
Your response must be concise. -51.04. What is the difference between the Area (% of total land area) in Argentina in 2010 and the Area (% of total land area) in Northern Mariana Islands in 2011?
Ensure brevity in your answer.  -55.09. What is the difference between the Area (% of total land area) in Montenegro in 2010 and the Area (% of total land area) in Northern Mariana Islands in 2011?
Offer a terse response. -4.06. What is the difference between the Area (% of total land area) of Fragile and conflict affected situations in 2010 and the Area (% of total land area) of Argentina in 2012?
Provide a short and direct response. 11.43. What is the difference between the Area (% of total land area) of Fragile and conflict affected situations in 2010 and the Area (% of total land area) of Montenegro in 2012?
Ensure brevity in your answer.  -39.83. What is the difference between the Area (% of total land area) in Fragile and conflict affected situations in 2010 and the Area (% of total land area) in Northern Mariana Islands in 2012?
Offer a terse response. -43.53. What is the difference between the Area (% of total land area) of Argentina in 2010 and the Area (% of total land area) of Montenegro in 2012?
Give a very brief answer. -51.04. What is the difference between the Area (% of total land area) of Argentina in 2010 and the Area (% of total land area) of Northern Mariana Islands in 2012?
Your answer should be compact. -54.75. What is the difference between the Area (% of total land area) in Montenegro in 2010 and the Area (% of total land area) in Northern Mariana Islands in 2012?
Make the answer very short. -3.71. What is the difference between the Area (% of total land area) in Fragile and conflict affected situations in 2011 and the Area (% of total land area) in Argentina in 2012?
Ensure brevity in your answer.  10.82. What is the difference between the Area (% of total land area) in Fragile and conflict affected situations in 2011 and the Area (% of total land area) in Montenegro in 2012?
Your response must be concise. -40.44. What is the difference between the Area (% of total land area) of Fragile and conflict affected situations in 2011 and the Area (% of total land area) of Northern Mariana Islands in 2012?
Provide a short and direct response. -44.15. What is the difference between the Area (% of total land area) in Argentina in 2011 and the Area (% of total land area) in Montenegro in 2012?
Ensure brevity in your answer.  -51.15. What is the difference between the Area (% of total land area) in Argentina in 2011 and the Area (% of total land area) in Northern Mariana Islands in 2012?
Make the answer very short. -54.85. What is the difference between the Area (% of total land area) in Montenegro in 2011 and the Area (% of total land area) in Northern Mariana Islands in 2012?
Give a very brief answer. -3.71. What is the average Area (% of total land area) in Fragile and conflict affected situations per year?
Your answer should be very brief. 21.69. What is the average Area (% of total land area) of Argentina per year?
Ensure brevity in your answer.  10.63. What is the average Area (% of total land area) in Montenegro per year?
Make the answer very short. 55.11. What is the average Area (% of total land area) in Northern Mariana Islands per year?
Keep it short and to the point. 66.45. In the year 2005, what is the difference between the Area (% of total land area) in Fragile and conflict affected situations and Area (% of total land area) in Argentina?
Offer a very short reply. 11.17. In the year 2005, what is the difference between the Area (% of total land area) in Fragile and conflict affected situations and Area (% of total land area) in Montenegro?
Make the answer very short. -18.17. In the year 2005, what is the difference between the Area (% of total land area) in Fragile and conflict affected situations and Area (% of total land area) in Northern Mariana Islands?
Give a very brief answer. -45.5. In the year 2005, what is the difference between the Area (% of total land area) of Argentina and Area (% of total land area) of Montenegro?
Ensure brevity in your answer.  -29.34. In the year 2005, what is the difference between the Area (% of total land area) in Argentina and Area (% of total land area) in Northern Mariana Islands?
Your answer should be very brief. -56.67. In the year 2005, what is the difference between the Area (% of total land area) in Montenegro and Area (% of total land area) in Northern Mariana Islands?
Offer a terse response. -27.32. In the year 2006, what is the difference between the Area (% of total land area) of Fragile and conflict affected situations and Area (% of total land area) of Argentina?
Offer a very short reply. 11.17. In the year 2006, what is the difference between the Area (% of total land area) in Fragile and conflict affected situations and Area (% of total land area) in Montenegro?
Keep it short and to the point. -27.44. In the year 2006, what is the difference between the Area (% of total land area) in Fragile and conflict affected situations and Area (% of total land area) in Northern Mariana Islands?
Your answer should be very brief. -45.26. In the year 2006, what is the difference between the Area (% of total land area) in Argentina and Area (% of total land area) in Montenegro?
Your answer should be very brief. -38.62. In the year 2006, what is the difference between the Area (% of total land area) of Argentina and Area (% of total land area) of Northern Mariana Islands?
Your answer should be compact. -56.43. In the year 2006, what is the difference between the Area (% of total land area) in Montenegro and Area (% of total land area) in Northern Mariana Islands?
Your answer should be very brief. -17.82. In the year 2007, what is the difference between the Area (% of total land area) of Fragile and conflict affected situations and Area (% of total land area) of Argentina?
Keep it short and to the point. 11.18. In the year 2007, what is the difference between the Area (% of total land area) of Fragile and conflict affected situations and Area (% of total land area) of Montenegro?
Your response must be concise. -30.54. In the year 2007, what is the difference between the Area (% of total land area) in Fragile and conflict affected situations and Area (% of total land area) in Northern Mariana Islands?
Give a very brief answer. -45. In the year 2007, what is the difference between the Area (% of total land area) of Argentina and Area (% of total land area) of Montenegro?
Offer a very short reply. -41.72. In the year 2007, what is the difference between the Area (% of total land area) in Argentina and Area (% of total land area) in Northern Mariana Islands?
Offer a terse response. -56.18. In the year 2007, what is the difference between the Area (% of total land area) in Montenegro and Area (% of total land area) in Northern Mariana Islands?
Your answer should be very brief. -14.46. In the year 2008, what is the difference between the Area (% of total land area) in Fragile and conflict affected situations and Area (% of total land area) in Argentina?
Make the answer very short. 11.19. In the year 2008, what is the difference between the Area (% of total land area) in Fragile and conflict affected situations and Area (% of total land area) in Montenegro?
Your answer should be compact. -33.64. In the year 2008, what is the difference between the Area (% of total land area) in Fragile and conflict affected situations and Area (% of total land area) in Northern Mariana Islands?
Make the answer very short. -44.76. In the year 2008, what is the difference between the Area (% of total land area) in Argentina and Area (% of total land area) in Montenegro?
Provide a short and direct response. -44.83. In the year 2008, what is the difference between the Area (% of total land area) in Argentina and Area (% of total land area) in Northern Mariana Islands?
Provide a short and direct response. -55.95. In the year 2008, what is the difference between the Area (% of total land area) in Montenegro and Area (% of total land area) in Northern Mariana Islands?
Provide a succinct answer. -11.12. In the year 2009, what is the difference between the Area (% of total land area) in Fragile and conflict affected situations and Area (% of total land area) in Argentina?
Keep it short and to the point. 11.2. In the year 2009, what is the difference between the Area (% of total land area) in Fragile and conflict affected situations and Area (% of total land area) in Montenegro?
Offer a very short reply. -36.73. In the year 2009, what is the difference between the Area (% of total land area) in Fragile and conflict affected situations and Area (% of total land area) in Northern Mariana Islands?
Your answer should be very brief. -44.49. In the year 2009, what is the difference between the Area (% of total land area) in Argentina and Area (% of total land area) in Montenegro?
Your response must be concise. -47.93. In the year 2009, what is the difference between the Area (% of total land area) of Argentina and Area (% of total land area) of Northern Mariana Islands?
Keep it short and to the point. -55.7. In the year 2009, what is the difference between the Area (% of total land area) of Montenegro and Area (% of total land area) of Northern Mariana Islands?
Offer a very short reply. -7.76. In the year 2010, what is the difference between the Area (% of total land area) of Fragile and conflict affected situations and Area (% of total land area) of Argentina?
Your answer should be compact. 11.21. In the year 2010, what is the difference between the Area (% of total land area) of Fragile and conflict affected situations and Area (% of total land area) of Montenegro?
Give a very brief answer. -39.83. In the year 2010, what is the difference between the Area (% of total land area) of Fragile and conflict affected situations and Area (% of total land area) of Northern Mariana Islands?
Offer a terse response. -44.25. In the year 2010, what is the difference between the Area (% of total land area) of Argentina and Area (% of total land area) of Montenegro?
Ensure brevity in your answer.  -51.04. In the year 2010, what is the difference between the Area (% of total land area) of Argentina and Area (% of total land area) of Northern Mariana Islands?
Keep it short and to the point. -55.46. In the year 2010, what is the difference between the Area (% of total land area) of Montenegro and Area (% of total land area) of Northern Mariana Islands?
Provide a succinct answer. -4.43. In the year 2011, what is the difference between the Area (% of total land area) of Fragile and conflict affected situations and Area (% of total land area) of Argentina?
Provide a succinct answer. 10.71. In the year 2011, what is the difference between the Area (% of total land area) of Fragile and conflict affected situations and Area (% of total land area) of Montenegro?
Your answer should be very brief. -40.44. In the year 2011, what is the difference between the Area (% of total land area) of Fragile and conflict affected situations and Area (% of total land area) of Northern Mariana Islands?
Provide a short and direct response. -44.5. In the year 2011, what is the difference between the Area (% of total land area) of Argentina and Area (% of total land area) of Montenegro?
Give a very brief answer. -51.15. In the year 2011, what is the difference between the Area (% of total land area) of Argentina and Area (% of total land area) of Northern Mariana Islands?
Your answer should be compact. -55.2. In the year 2011, what is the difference between the Area (% of total land area) of Montenegro and Area (% of total land area) of Northern Mariana Islands?
Provide a succinct answer. -4.06. In the year 2012, what is the difference between the Area (% of total land area) in Fragile and conflict affected situations and Area (% of total land area) in Argentina?
Your answer should be very brief. 10.7. In the year 2012, what is the difference between the Area (% of total land area) of Fragile and conflict affected situations and Area (% of total land area) of Montenegro?
Make the answer very short. -40.56. In the year 2012, what is the difference between the Area (% of total land area) in Fragile and conflict affected situations and Area (% of total land area) in Northern Mariana Islands?
Ensure brevity in your answer.  -44.26. In the year 2012, what is the difference between the Area (% of total land area) in Argentina and Area (% of total land area) in Montenegro?
Your response must be concise. -51.25. In the year 2012, what is the difference between the Area (% of total land area) in Argentina and Area (% of total land area) in Northern Mariana Islands?
Give a very brief answer. -54.96. In the year 2012, what is the difference between the Area (% of total land area) in Montenegro and Area (% of total land area) in Northern Mariana Islands?
Ensure brevity in your answer.  -3.71. What is the ratio of the Area (% of total land area) of Argentina in 2005 to that in 2006?
Provide a succinct answer. 1.01. What is the ratio of the Area (% of total land area) of Montenegro in 2005 to that in 2006?
Your response must be concise. 0.82. What is the ratio of the Area (% of total land area) in Northern Mariana Islands in 2005 to that in 2006?
Make the answer very short. 1.01. What is the ratio of the Area (% of total land area) of Fragile and conflict affected situations in 2005 to that in 2007?
Provide a succinct answer. 1.01. What is the ratio of the Area (% of total land area) of Argentina in 2005 to that in 2007?
Provide a short and direct response. 1.02. What is the ratio of the Area (% of total land area) in Montenegro in 2005 to that in 2007?
Make the answer very short. 0.77. What is the ratio of the Area (% of total land area) in Northern Mariana Islands in 2005 to that in 2007?
Your response must be concise. 1.01. What is the ratio of the Area (% of total land area) of Fragile and conflict affected situations in 2005 to that in 2008?
Give a very brief answer. 1.01. What is the ratio of the Area (% of total land area) in Argentina in 2005 to that in 2008?
Make the answer very short. 1.03. What is the ratio of the Area (% of total land area) of Montenegro in 2005 to that in 2008?
Provide a short and direct response. 0.73. What is the ratio of the Area (% of total land area) of Northern Mariana Islands in 2005 to that in 2008?
Ensure brevity in your answer.  1.02. What is the ratio of the Area (% of total land area) in Fragile and conflict affected situations in 2005 to that in 2009?
Your answer should be compact. 1.02. What is the ratio of the Area (% of total land area) of Argentina in 2005 to that in 2009?
Keep it short and to the point. 1.04. What is the ratio of the Area (% of total land area) in Montenegro in 2005 to that in 2009?
Provide a succinct answer. 0.69. What is the ratio of the Area (% of total land area) of Northern Mariana Islands in 2005 to that in 2009?
Your answer should be very brief. 1.02. What is the ratio of the Area (% of total land area) in Fragile and conflict affected situations in 2005 to that in 2010?
Your response must be concise. 1.02. What is the ratio of the Area (% of total land area) of Argentina in 2005 to that in 2010?
Your answer should be very brief. 1.06. What is the ratio of the Area (% of total land area) in Montenegro in 2005 to that in 2010?
Give a very brief answer. 0.66. What is the ratio of the Area (% of total land area) in Fragile and conflict affected situations in 2005 to that in 2011?
Your answer should be compact. 1.05. What is the ratio of the Area (% of total land area) of Argentina in 2005 to that in 2011?
Ensure brevity in your answer.  1.07. What is the ratio of the Area (% of total land area) of Montenegro in 2005 to that in 2011?
Offer a very short reply. 0.66. What is the ratio of the Area (% of total land area) in Northern Mariana Islands in 2005 to that in 2011?
Your answer should be compact. 1.03. What is the ratio of the Area (% of total land area) of Fragile and conflict affected situations in 2005 to that in 2012?
Provide a short and direct response. 1.06. What is the ratio of the Area (% of total land area) in Argentina in 2005 to that in 2012?
Ensure brevity in your answer.  1.08. What is the ratio of the Area (% of total land area) of Montenegro in 2005 to that in 2012?
Offer a very short reply. 0.66. What is the ratio of the Area (% of total land area) of Northern Mariana Islands in 2005 to that in 2012?
Make the answer very short. 1.04. What is the ratio of the Area (% of total land area) of Argentina in 2006 to that in 2007?
Offer a terse response. 1.01. What is the ratio of the Area (% of total land area) in Montenegro in 2006 to that in 2007?
Make the answer very short. 0.94. What is the ratio of the Area (% of total land area) of Northern Mariana Islands in 2006 to that in 2007?
Make the answer very short. 1.01. What is the ratio of the Area (% of total land area) in Fragile and conflict affected situations in 2006 to that in 2008?
Your answer should be very brief. 1.01. What is the ratio of the Area (% of total land area) in Argentina in 2006 to that in 2008?
Your answer should be compact. 1.02. What is the ratio of the Area (% of total land area) of Montenegro in 2006 to that in 2008?
Provide a short and direct response. 0.89. What is the ratio of the Area (% of total land area) of Northern Mariana Islands in 2006 to that in 2008?
Provide a short and direct response. 1.01. What is the ratio of the Area (% of total land area) in Fragile and conflict affected situations in 2006 to that in 2009?
Give a very brief answer. 1.01. What is the ratio of the Area (% of total land area) of Argentina in 2006 to that in 2009?
Provide a succinct answer. 1.03. What is the ratio of the Area (% of total land area) of Montenegro in 2006 to that in 2009?
Your response must be concise. 0.85. What is the ratio of the Area (% of total land area) in Northern Mariana Islands in 2006 to that in 2009?
Your answer should be compact. 1.02. What is the ratio of the Area (% of total land area) in Fragile and conflict affected situations in 2006 to that in 2010?
Provide a short and direct response. 1.02. What is the ratio of the Area (% of total land area) in Argentina in 2006 to that in 2010?
Make the answer very short. 1.04. What is the ratio of the Area (% of total land area) of Montenegro in 2006 to that in 2010?
Ensure brevity in your answer.  0.81. What is the ratio of the Area (% of total land area) in Northern Mariana Islands in 2006 to that in 2010?
Your answer should be compact. 1.02. What is the ratio of the Area (% of total land area) in Fragile and conflict affected situations in 2006 to that in 2011?
Your answer should be very brief. 1.05. What is the ratio of the Area (% of total land area) in Argentina in 2006 to that in 2011?
Your answer should be very brief. 1.06. What is the ratio of the Area (% of total land area) of Montenegro in 2006 to that in 2011?
Keep it short and to the point. 0.81. What is the ratio of the Area (% of total land area) in Northern Mariana Islands in 2006 to that in 2011?
Provide a succinct answer. 1.03. What is the ratio of the Area (% of total land area) in Fragile and conflict affected situations in 2006 to that in 2012?
Give a very brief answer. 1.06. What is the ratio of the Area (% of total land area) of Argentina in 2006 to that in 2012?
Ensure brevity in your answer.  1.07. What is the ratio of the Area (% of total land area) in Montenegro in 2006 to that in 2012?
Offer a terse response. 0.81. What is the ratio of the Area (% of total land area) in Northern Mariana Islands in 2006 to that in 2012?
Give a very brief answer. 1.03. What is the ratio of the Area (% of total land area) of Argentina in 2007 to that in 2008?
Make the answer very short. 1.01. What is the ratio of the Area (% of total land area) in Montenegro in 2007 to that in 2008?
Make the answer very short. 0.95. What is the ratio of the Area (% of total land area) in Northern Mariana Islands in 2007 to that in 2008?
Offer a terse response. 1.01. What is the ratio of the Area (% of total land area) of Fragile and conflict affected situations in 2007 to that in 2009?
Your answer should be compact. 1.01. What is the ratio of the Area (% of total land area) in Montenegro in 2007 to that in 2009?
Offer a very short reply. 0.9. What is the ratio of the Area (% of total land area) of Northern Mariana Islands in 2007 to that in 2009?
Give a very brief answer. 1.01. What is the ratio of the Area (% of total land area) in Fragile and conflict affected situations in 2007 to that in 2010?
Offer a terse response. 1.01. What is the ratio of the Area (% of total land area) of Argentina in 2007 to that in 2010?
Give a very brief answer. 1.03. What is the ratio of the Area (% of total land area) in Montenegro in 2007 to that in 2010?
Provide a succinct answer. 0.85. What is the ratio of the Area (% of total land area) of Northern Mariana Islands in 2007 to that in 2010?
Provide a succinct answer. 1.02. What is the ratio of the Area (% of total land area) in Fragile and conflict affected situations in 2007 to that in 2011?
Your answer should be very brief. 1.04. What is the ratio of the Area (% of total land area) in Argentina in 2007 to that in 2011?
Your response must be concise. 1.04. What is the ratio of the Area (% of total land area) in Montenegro in 2007 to that in 2011?
Your answer should be very brief. 0.85. What is the ratio of the Area (% of total land area) in Northern Mariana Islands in 2007 to that in 2011?
Give a very brief answer. 1.02. What is the ratio of the Area (% of total land area) of Fragile and conflict affected situations in 2007 to that in 2012?
Ensure brevity in your answer.  1.05. What is the ratio of the Area (% of total land area) of Argentina in 2007 to that in 2012?
Ensure brevity in your answer.  1.06. What is the ratio of the Area (% of total land area) of Montenegro in 2007 to that in 2012?
Your response must be concise. 0.85. What is the ratio of the Area (% of total land area) in Northern Mariana Islands in 2007 to that in 2012?
Your answer should be very brief. 1.03. What is the ratio of the Area (% of total land area) of Fragile and conflict affected situations in 2008 to that in 2009?
Provide a short and direct response. 1. What is the ratio of the Area (% of total land area) in Montenegro in 2008 to that in 2009?
Your response must be concise. 0.95. What is the ratio of the Area (% of total land area) in Northern Mariana Islands in 2008 to that in 2009?
Make the answer very short. 1.01. What is the ratio of the Area (% of total land area) in Fragile and conflict affected situations in 2008 to that in 2010?
Make the answer very short. 1.01. What is the ratio of the Area (% of total land area) of Argentina in 2008 to that in 2010?
Provide a short and direct response. 1.02. What is the ratio of the Area (% of total land area) in Montenegro in 2008 to that in 2010?
Provide a short and direct response. 0.9. What is the ratio of the Area (% of total land area) of Northern Mariana Islands in 2008 to that in 2010?
Offer a terse response. 1.01. What is the ratio of the Area (% of total land area) in Fragile and conflict affected situations in 2008 to that in 2011?
Ensure brevity in your answer.  1.04. What is the ratio of the Area (% of total land area) in Argentina in 2008 to that in 2011?
Give a very brief answer. 1.03. What is the ratio of the Area (% of total land area) in Montenegro in 2008 to that in 2011?
Your response must be concise. 0.9. What is the ratio of the Area (% of total land area) of Northern Mariana Islands in 2008 to that in 2011?
Provide a succinct answer. 1.02. What is the ratio of the Area (% of total land area) of Fragile and conflict affected situations in 2008 to that in 2012?
Keep it short and to the point. 1.04. What is the ratio of the Area (% of total land area) of Argentina in 2008 to that in 2012?
Your response must be concise. 1.04. What is the ratio of the Area (% of total land area) of Montenegro in 2008 to that in 2012?
Your response must be concise. 0.9. What is the ratio of the Area (% of total land area) in Northern Mariana Islands in 2008 to that in 2012?
Keep it short and to the point. 1.02. What is the ratio of the Area (% of total land area) of Argentina in 2009 to that in 2010?
Ensure brevity in your answer.  1.01. What is the ratio of the Area (% of total land area) in Montenegro in 2009 to that in 2010?
Offer a terse response. 0.95. What is the ratio of the Area (% of total land area) in Northern Mariana Islands in 2009 to that in 2010?
Provide a succinct answer. 1.01. What is the ratio of the Area (% of total land area) of Fragile and conflict affected situations in 2009 to that in 2011?
Provide a short and direct response. 1.03. What is the ratio of the Area (% of total land area) of Argentina in 2009 to that in 2011?
Make the answer very short. 1.02. What is the ratio of the Area (% of total land area) of Montenegro in 2009 to that in 2011?
Offer a very short reply. 0.95. What is the ratio of the Area (% of total land area) in Northern Mariana Islands in 2009 to that in 2011?
Offer a terse response. 1.01. What is the ratio of the Area (% of total land area) of Fragile and conflict affected situations in 2009 to that in 2012?
Make the answer very short. 1.04. What is the ratio of the Area (% of total land area) of Argentina in 2009 to that in 2012?
Keep it short and to the point. 1.03. What is the ratio of the Area (% of total land area) of Montenegro in 2009 to that in 2012?
Provide a succinct answer. 0.95. What is the ratio of the Area (% of total land area) of Northern Mariana Islands in 2009 to that in 2012?
Ensure brevity in your answer.  1.02. What is the ratio of the Area (% of total land area) in Fragile and conflict affected situations in 2010 to that in 2011?
Offer a terse response. 1.03. What is the ratio of the Area (% of total land area) in Argentina in 2010 to that in 2011?
Keep it short and to the point. 1.01. What is the ratio of the Area (% of total land area) in Northern Mariana Islands in 2010 to that in 2011?
Give a very brief answer. 1.01. What is the ratio of the Area (% of total land area) in Fragile and conflict affected situations in 2010 to that in 2012?
Ensure brevity in your answer.  1.03. What is the ratio of the Area (% of total land area) in Argentina in 2010 to that in 2012?
Provide a short and direct response. 1.02. What is the ratio of the Area (% of total land area) of Northern Mariana Islands in 2010 to that in 2012?
Your answer should be compact. 1.01. What is the ratio of the Area (% of total land area) of Fragile and conflict affected situations in 2011 to that in 2012?
Your response must be concise. 1.01. What is the ratio of the Area (% of total land area) of Argentina in 2011 to that in 2012?
Your response must be concise. 1.01. What is the ratio of the Area (% of total land area) in Montenegro in 2011 to that in 2012?
Your response must be concise. 1. What is the difference between the highest and the second highest Area (% of total land area) in Fragile and conflict affected situations?
Keep it short and to the point. 0.11. What is the difference between the highest and the second highest Area (% of total land area) in Argentina?
Offer a very short reply. 0.12. What is the difference between the highest and the second highest Area (% of total land area) of Montenegro?
Offer a terse response. 0. What is the difference between the highest and the second highest Area (% of total land area) of Northern Mariana Islands?
Keep it short and to the point. 0.35. What is the difference between the highest and the lowest Area (% of total land area) of Fragile and conflict affected situations?
Your answer should be very brief. 1.27. What is the difference between the highest and the lowest Area (% of total land area) of Argentina?
Offer a very short reply. 0.8. What is the difference between the highest and the lowest Area (% of total land area) in Montenegro?
Your response must be concise. 21.12. 